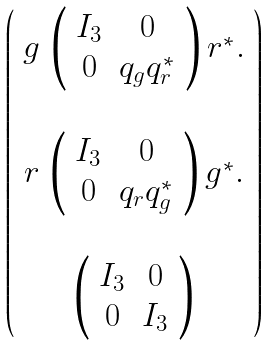<formula> <loc_0><loc_0><loc_500><loc_500>\left ( \begin{array} { c } g \, \left ( \begin{array} { c c } I _ { 3 } & 0 \\ 0 & q _ { g } q ^ { * } _ { r } \end{array} \right ) r ^ { * } . \\ \\ r \, \left ( \begin{array} { c c } I _ { 3 } & 0 \\ 0 & q _ { r } q ^ { * } _ { g } \end{array} \right ) g ^ { * } . \\ \\ \left ( \begin{array} { c c } I _ { 3 } & 0 \\ 0 & I _ { 3 } \end{array} \right ) \end{array} \right )</formula> 